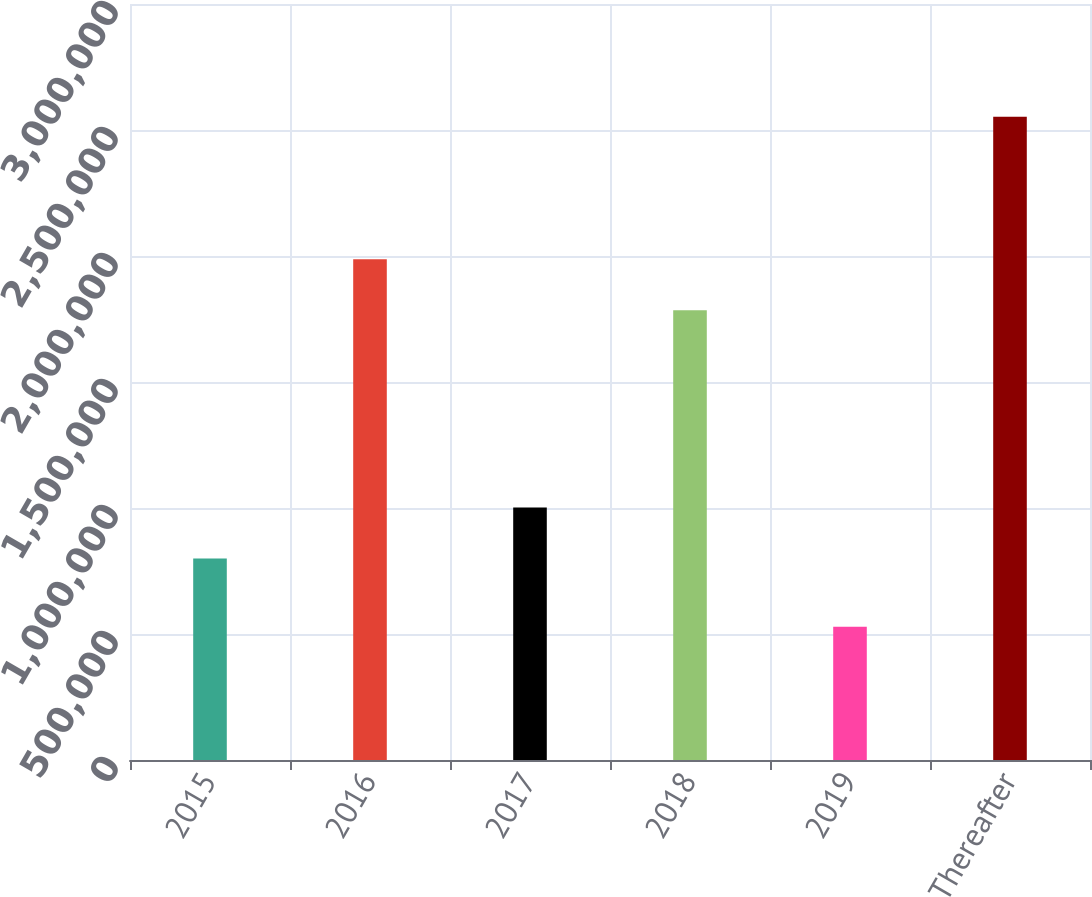Convert chart to OTSL. <chart><loc_0><loc_0><loc_500><loc_500><bar_chart><fcel>2015<fcel>2016<fcel>2017<fcel>2018<fcel>2019<fcel>Thereafter<nl><fcel>799630<fcel>1.98747e+06<fcel>1.00202e+06<fcel>1.78508e+06<fcel>529197<fcel>2.55305e+06<nl></chart> 